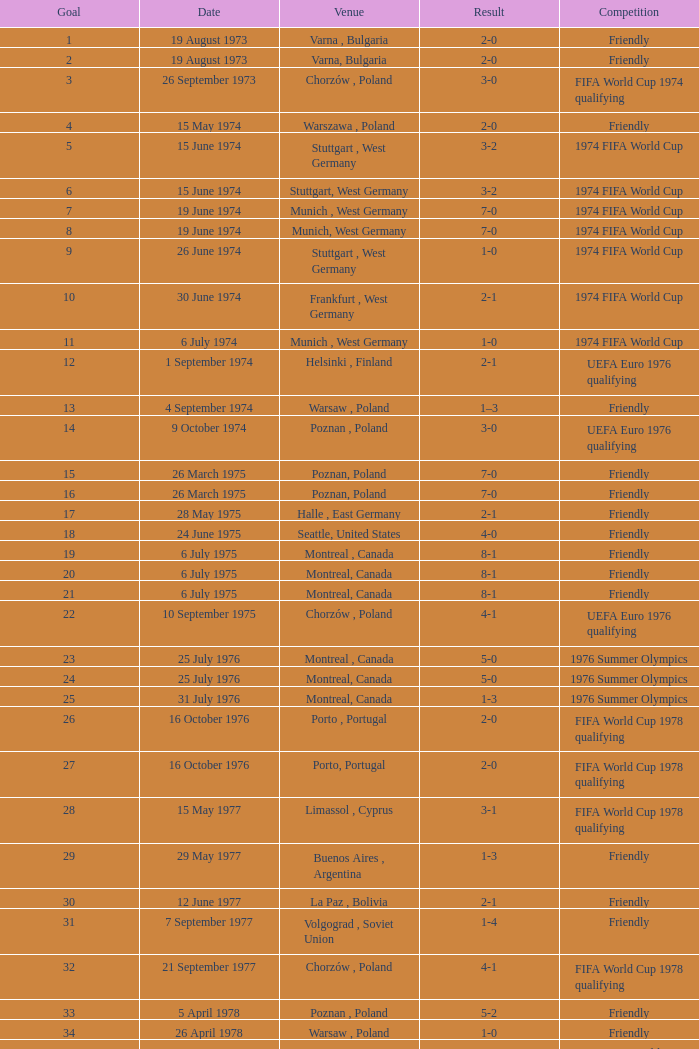What was the result of the game in Stuttgart, West Germany and a goal number of less than 9? 3-2, 3-2. 